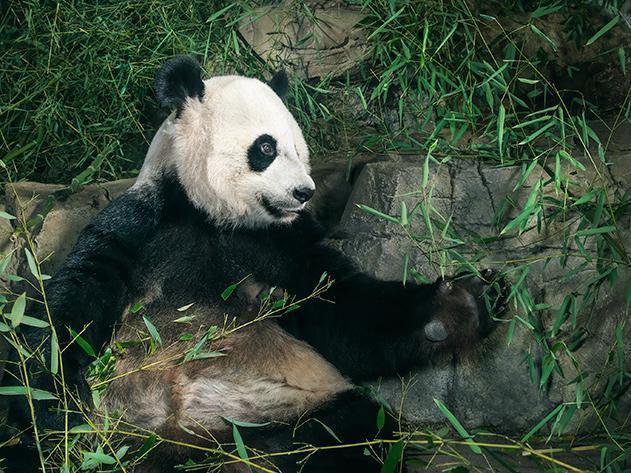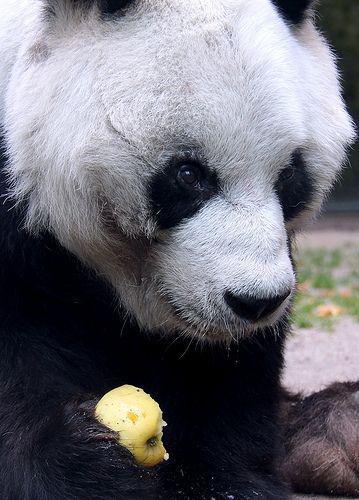The first image is the image on the left, the second image is the image on the right. Given the left and right images, does the statement "The panda in the image on the left is sitting near an upright post." hold true? Answer yes or no. No. The first image is the image on the left, the second image is the image on the right. Given the left and right images, does the statement "The panda on the left is looking toward the camera and holding a roundish-shaped food near its mouth." hold true? Answer yes or no. No. 